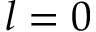<formula> <loc_0><loc_0><loc_500><loc_500>l = 0</formula> 